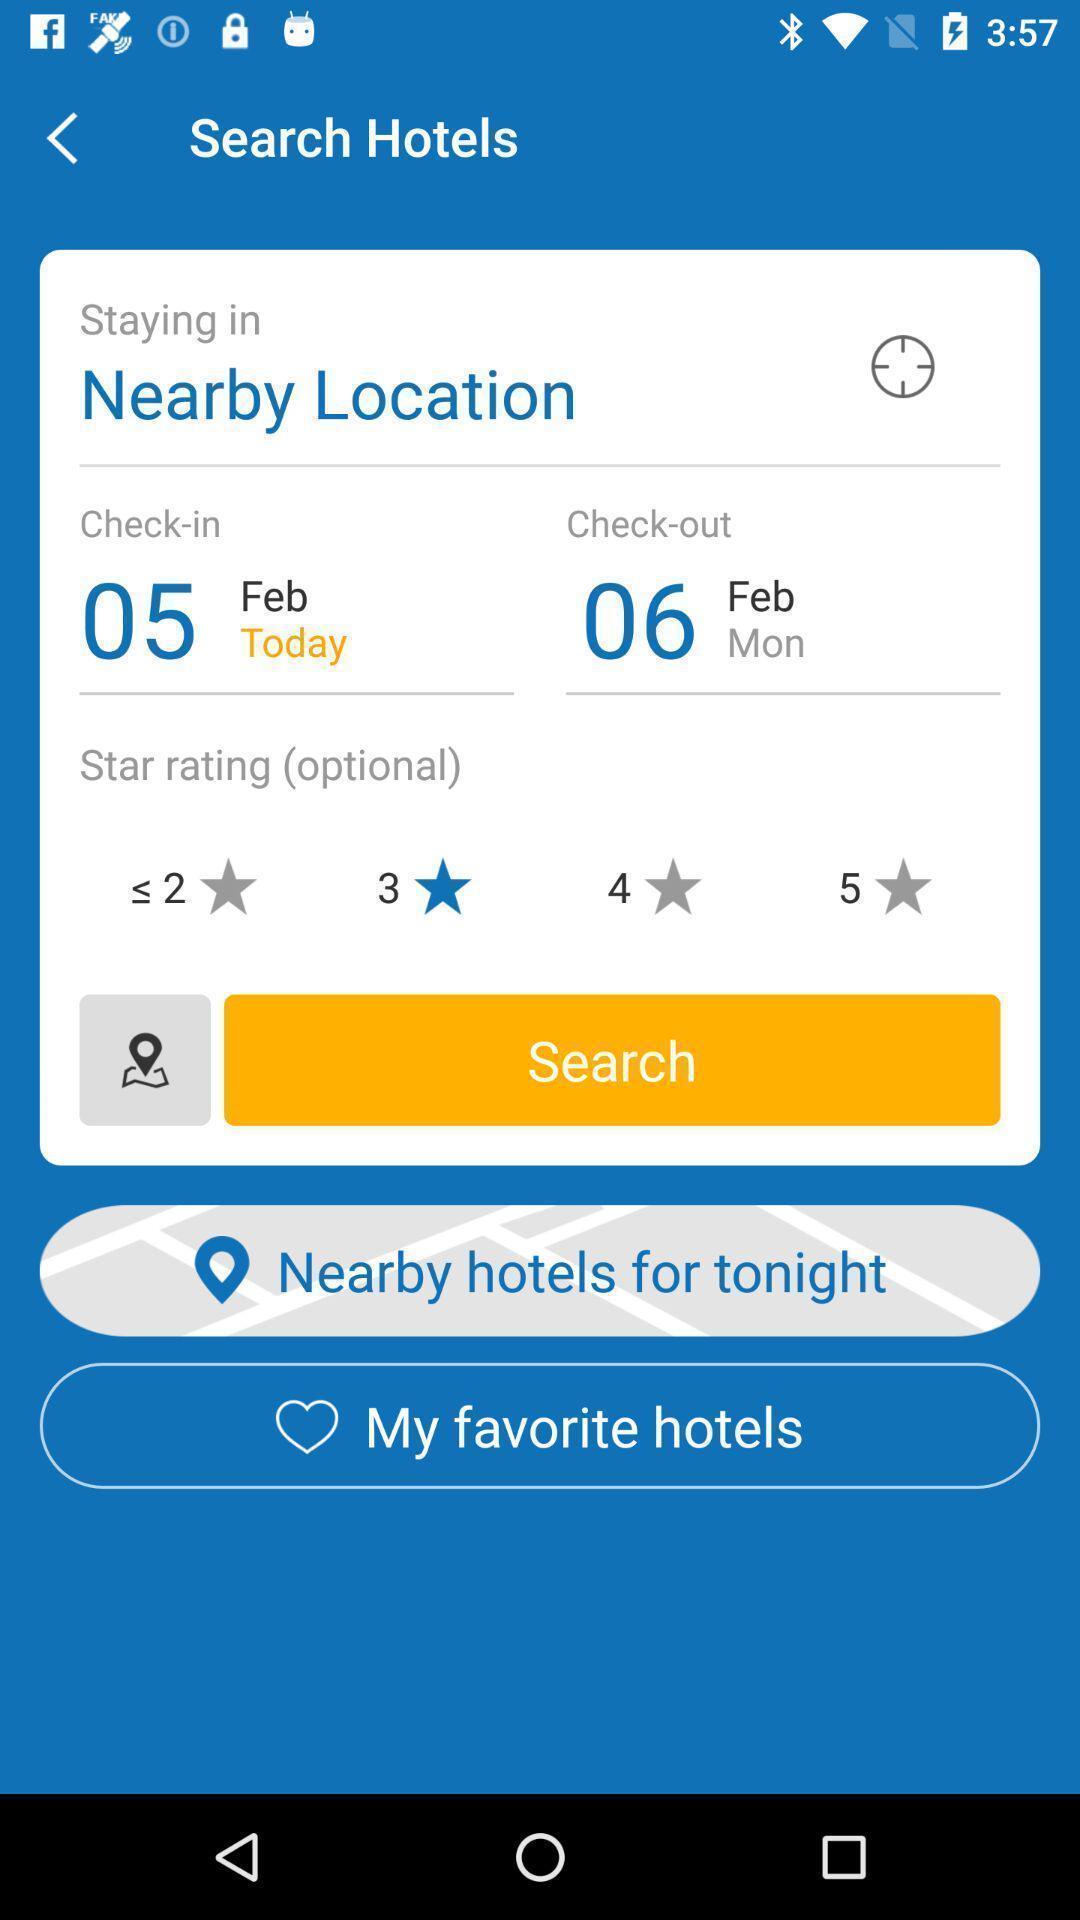Describe the content in this image. Screen shows search hotels page in travel app. 